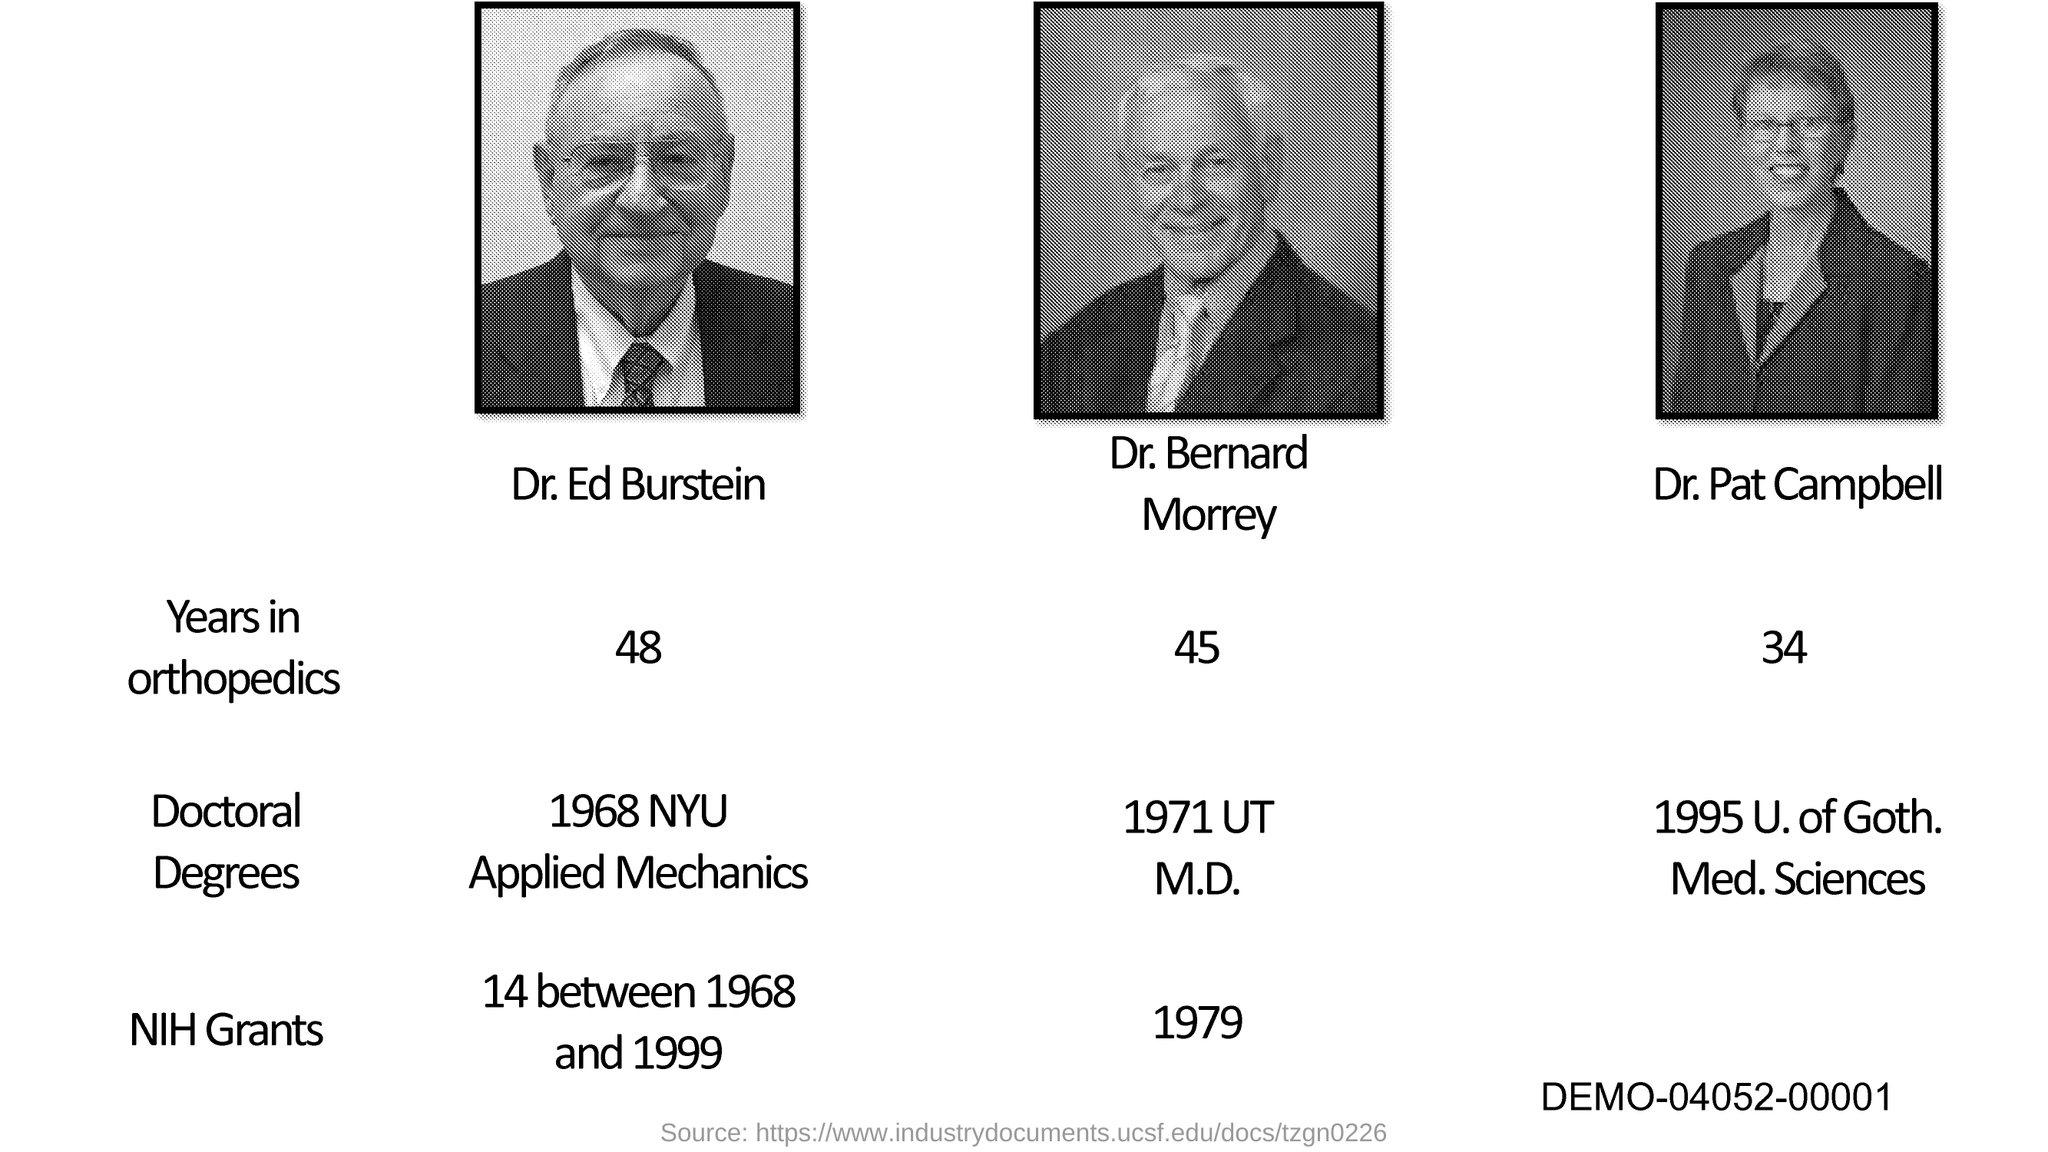Point out several critical features in this image. Dr. Ed Burstein has 48 years of experience in the field of orthopedics. According to information available, Dr. Bernard Morrey has accumulated 45 years of experience in the field of orthopedics. Dr. Pat Campbell has a total of 34 years of experience in the field of orthopedics. Dr. Pat Campbell obtained his doctoral degree in 1995 from the University of Gothenburg Medical Sciences. Dr. Bernard Morrey received NIH grants in the year 1979. 